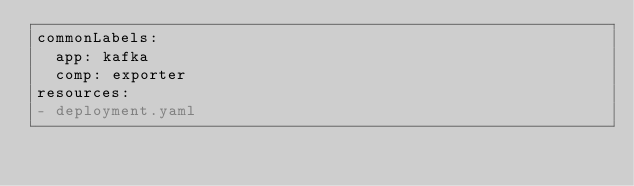<code> <loc_0><loc_0><loc_500><loc_500><_YAML_>commonLabels:
  app: kafka
  comp: exporter
resources:
- deployment.yaml
</code> 